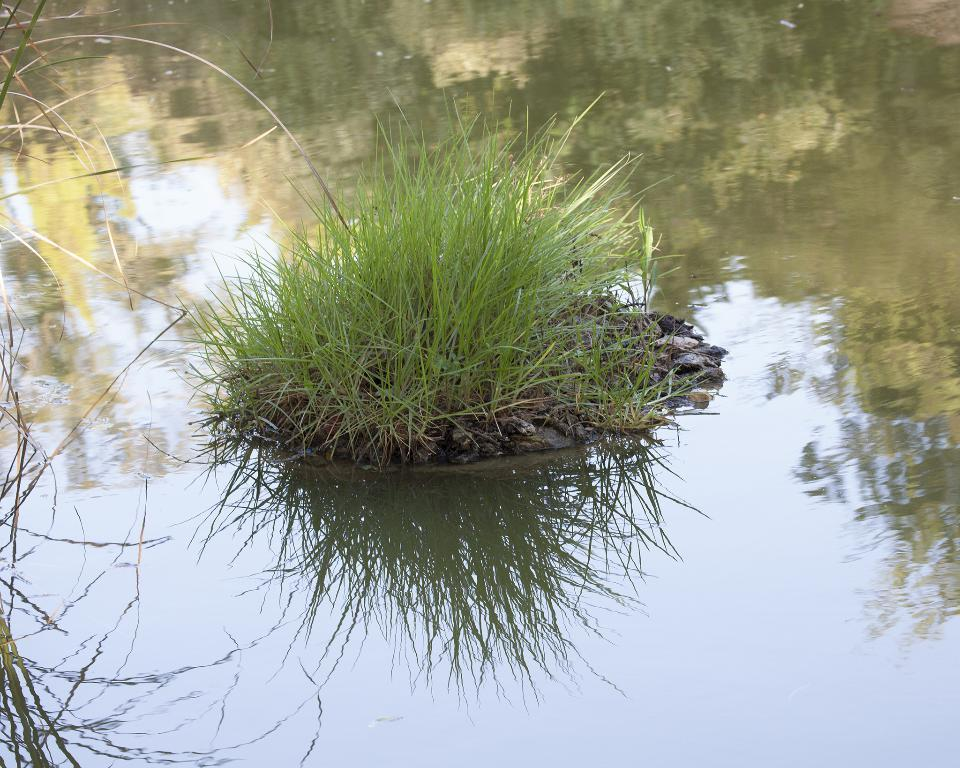What is present in the center and left side of the image? There are plants in the center and left side of the image. What can be observed in the image due to the presence of water? The water in the image reflects the trees. What is visible in the water's reflection? Trees are visible in the water's reflection. How many brothers can be seen in the image? There are no brothers present in the image. What is the girl doing in the image? There is no girl present in the image. 